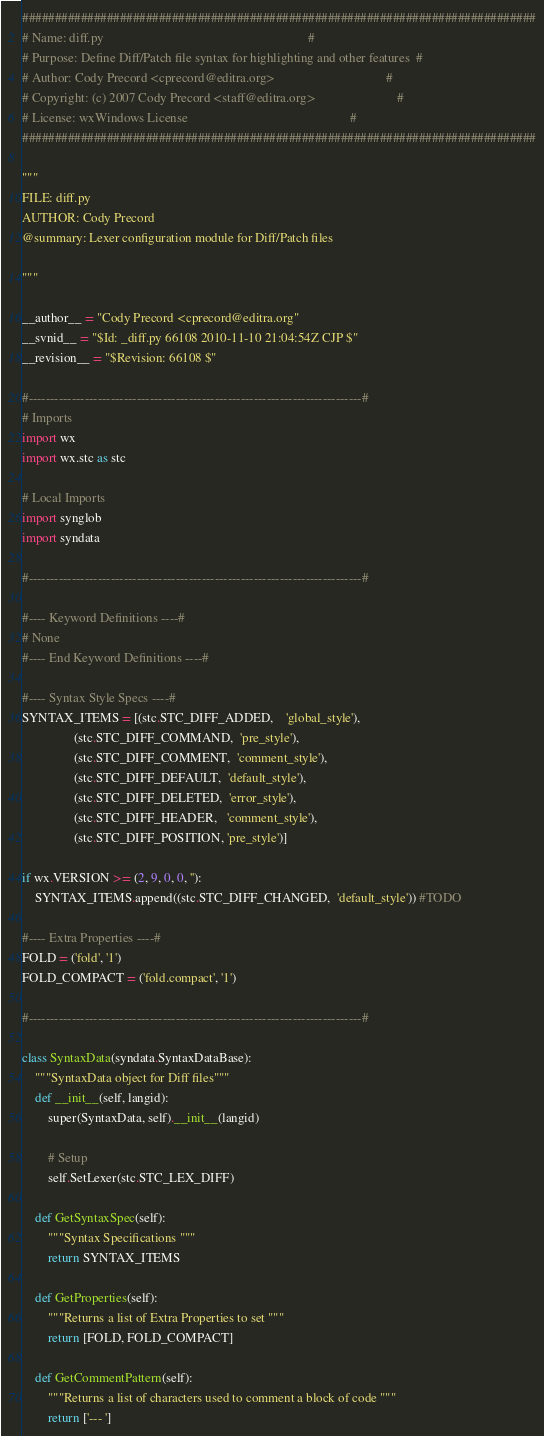<code> <loc_0><loc_0><loc_500><loc_500><_Python_>###############################################################################
# Name: diff.py                                                               #
# Purpose: Define Diff/Patch file syntax for highlighting and other features  #
# Author: Cody Precord <cprecord@editra.org>                                  #
# Copyright: (c) 2007 Cody Precord <staff@editra.org>                         #
# License: wxWindows License                                                  #
###############################################################################

"""
FILE: diff.py
AUTHOR: Cody Precord
@summary: Lexer configuration module for Diff/Patch files

"""

__author__ = "Cody Precord <cprecord@editra.org"
__svnid__ = "$Id: _diff.py 66108 2010-11-10 21:04:54Z CJP $"
__revision__ = "$Revision: 66108 $"

#-----------------------------------------------------------------------------#
# Imports
import wx
import wx.stc as stc

# Local Imports
import synglob
import syndata

#-----------------------------------------------------------------------------#

#---- Keyword Definitions ----#
# None
#---- End Keyword Definitions ----#

#---- Syntax Style Specs ----#
SYNTAX_ITEMS = [(stc.STC_DIFF_ADDED,    'global_style'),
                (stc.STC_DIFF_COMMAND,  'pre_style'),
                (stc.STC_DIFF_COMMENT,  'comment_style'),
                (stc.STC_DIFF_DEFAULT,  'default_style'),
                (stc.STC_DIFF_DELETED,  'error_style'),
                (stc.STC_DIFF_HEADER,   'comment_style'),
                (stc.STC_DIFF_POSITION, 'pre_style')]

if wx.VERSION >= (2, 9, 0, 0, ''):
    SYNTAX_ITEMS.append((stc.STC_DIFF_CHANGED,  'default_style')) #TODO

#---- Extra Properties ----#
FOLD = ('fold', '1')
FOLD_COMPACT = ('fold.compact', '1')

#-----------------------------------------------------------------------------#

class SyntaxData(syndata.SyntaxDataBase):
    """SyntaxData object for Diff files""" 
    def __init__(self, langid):
        super(SyntaxData, self).__init__(langid)

        # Setup
        self.SetLexer(stc.STC_LEX_DIFF)

    def GetSyntaxSpec(self):
        """Syntax Specifications """
        return SYNTAX_ITEMS

    def GetProperties(self):
        """Returns a list of Extra Properties to set """
        return [FOLD, FOLD_COMPACT]

    def GetCommentPattern(self):
        """Returns a list of characters used to comment a block of code """
        return ['--- ']
</code> 